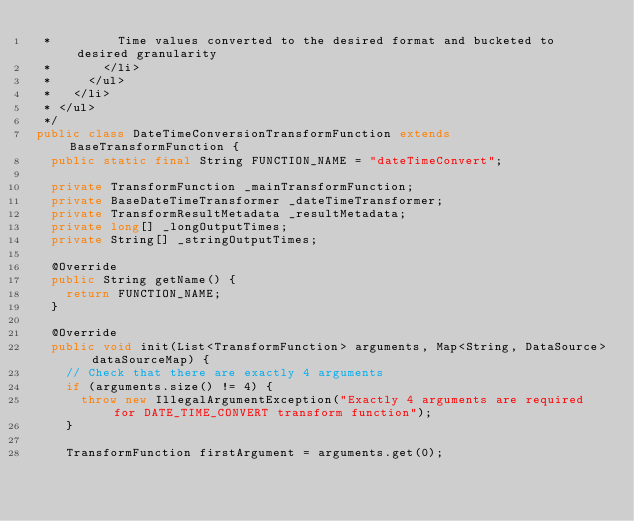Convert code to text. <code><loc_0><loc_0><loc_500><loc_500><_Java_> *         Time values converted to the desired format and bucketed to desired granularity
 *       </li>
 *     </ul>
 *   </li>
 * </ul>
 */
public class DateTimeConversionTransformFunction extends BaseTransformFunction {
  public static final String FUNCTION_NAME = "dateTimeConvert";

  private TransformFunction _mainTransformFunction;
  private BaseDateTimeTransformer _dateTimeTransformer;
  private TransformResultMetadata _resultMetadata;
  private long[] _longOutputTimes;
  private String[] _stringOutputTimes;

  @Override
  public String getName() {
    return FUNCTION_NAME;
  }

  @Override
  public void init(List<TransformFunction> arguments, Map<String, DataSource> dataSourceMap) {
    // Check that there are exactly 4 arguments
    if (arguments.size() != 4) {
      throw new IllegalArgumentException("Exactly 4 arguments are required for DATE_TIME_CONVERT transform function");
    }

    TransformFunction firstArgument = arguments.get(0);</code> 